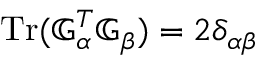Convert formula to latex. <formula><loc_0><loc_0><loc_500><loc_500>T r ( { \mathbb { G } } _ { \alpha } ^ { T } { \mathbb { G } } _ { \beta } ) = 2 \delta _ { \alpha \beta }</formula> 